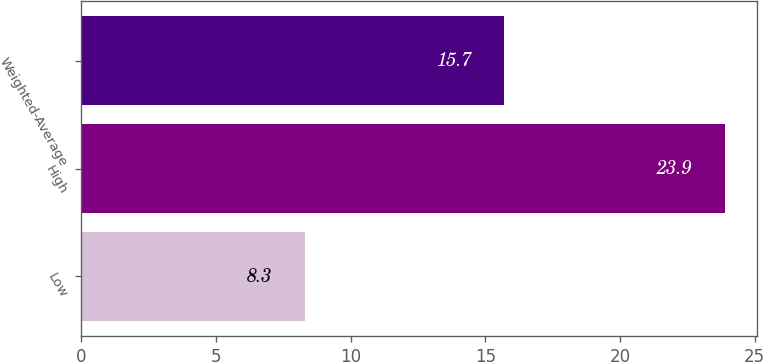Convert chart. <chart><loc_0><loc_0><loc_500><loc_500><bar_chart><fcel>Low<fcel>High<fcel>Weighted-Average<nl><fcel>8.3<fcel>23.9<fcel>15.7<nl></chart> 